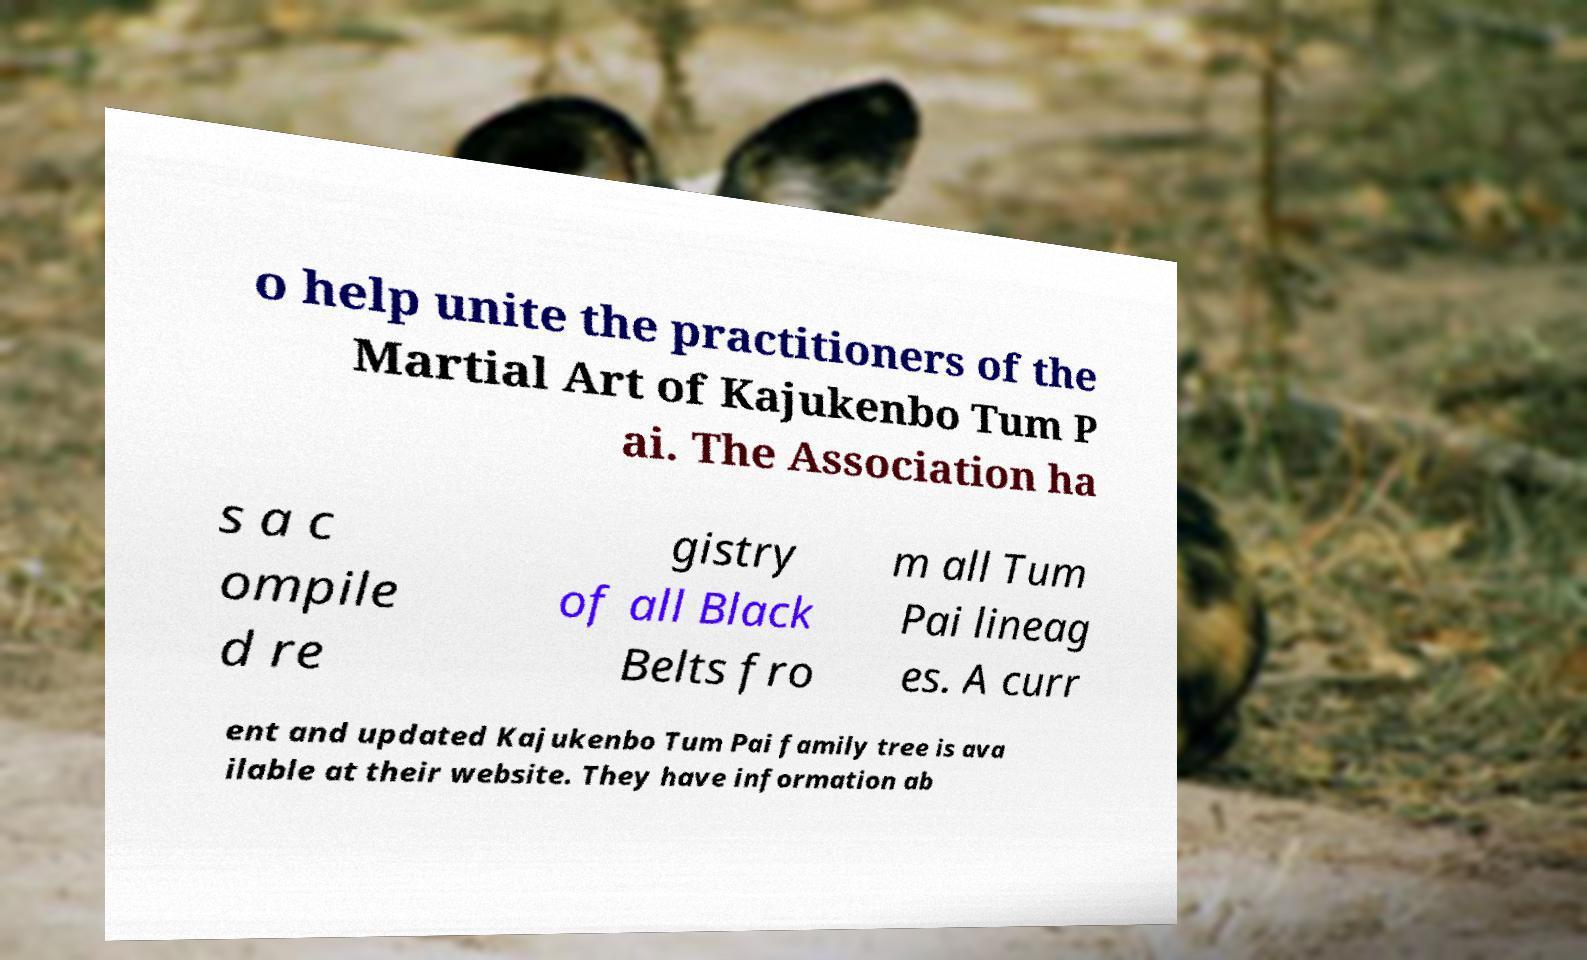For documentation purposes, I need the text within this image transcribed. Could you provide that? o help unite the practitioners of the Martial Art of Kajukenbo Tum P ai. The Association ha s a c ompile d re gistry of all Black Belts fro m all Tum Pai lineag es. A curr ent and updated Kajukenbo Tum Pai family tree is ava ilable at their website. They have information ab 